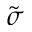<formula> <loc_0><loc_0><loc_500><loc_500>\tilde { \sigma }</formula> 